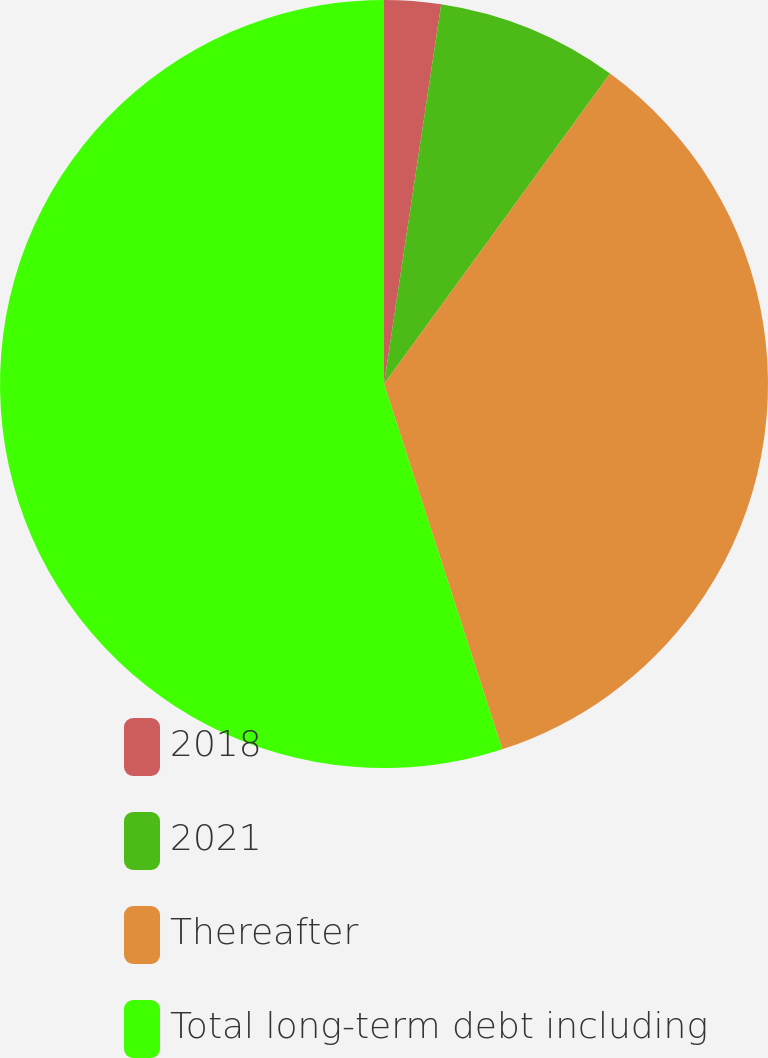Convert chart to OTSL. <chart><loc_0><loc_0><loc_500><loc_500><pie_chart><fcel>2018<fcel>2021<fcel>Thereafter<fcel>Total long-term debt including<nl><fcel>2.38%<fcel>7.64%<fcel>35.0%<fcel>54.98%<nl></chart> 